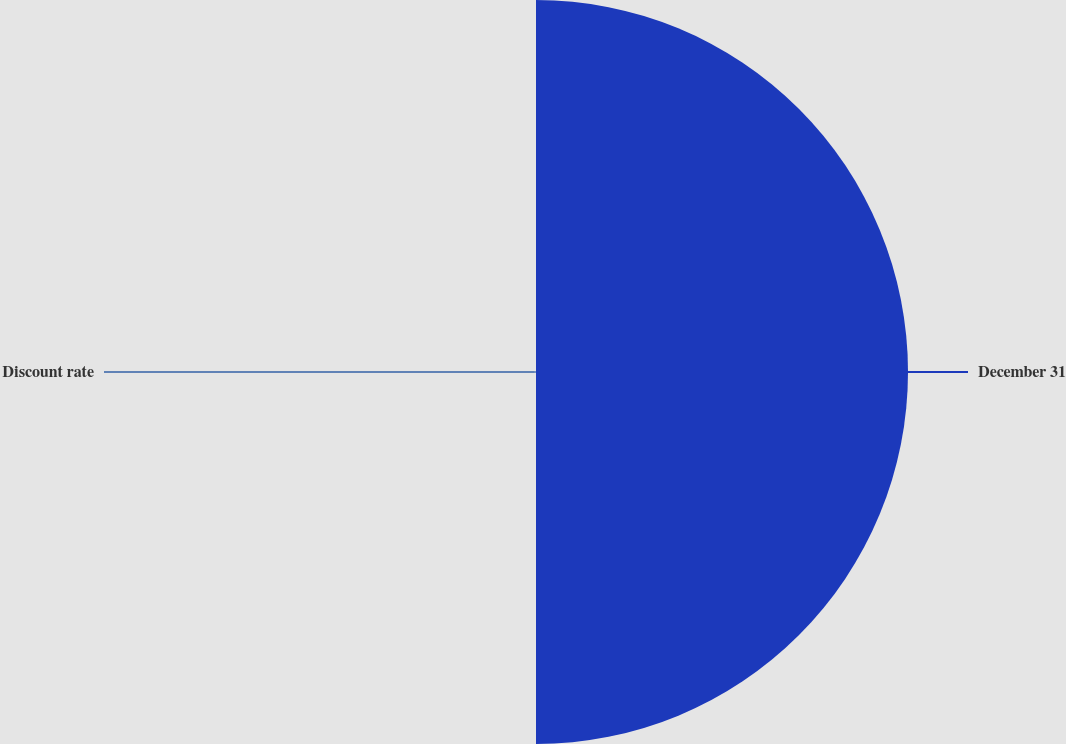<chart> <loc_0><loc_0><loc_500><loc_500><pie_chart><fcel>December 31<fcel>Discount rate<nl><fcel>99.7%<fcel>0.3%<nl></chart> 